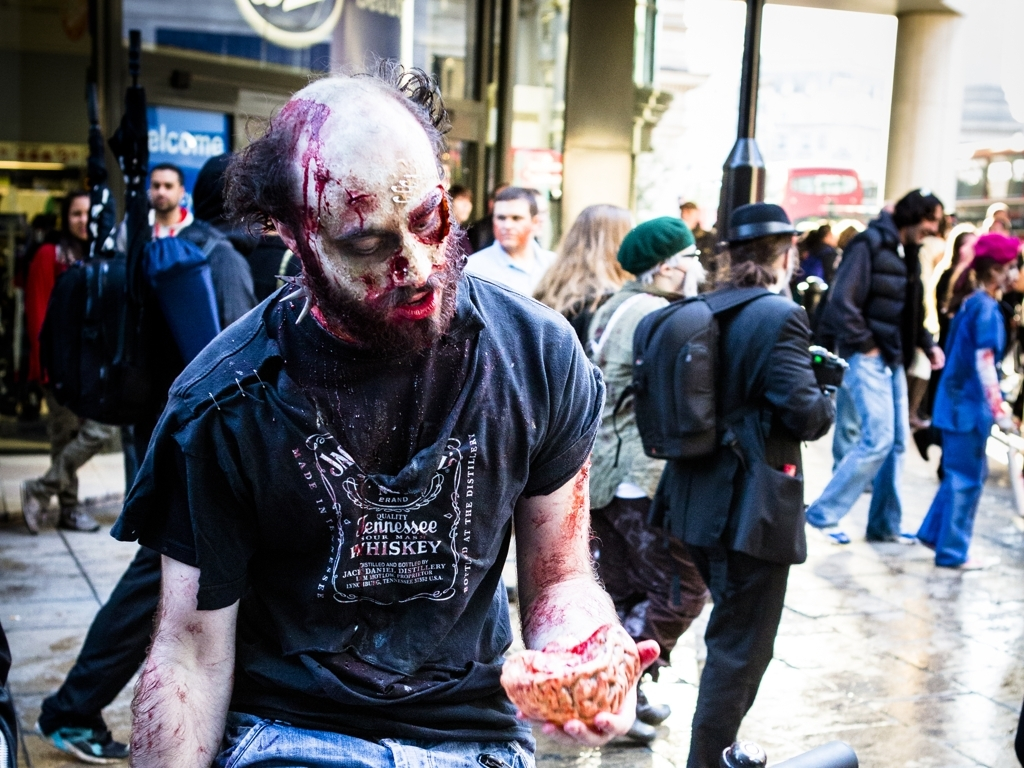Can you describe the person's attire and makeup? Certainly! The individual in the photo is wearing a short-sleeved, black T-shirt with a logo that reads 'Tennessee Whiskey Jack Daniel' on it, suggesting a casual attire. The notable aspect of their appearance, however, is the extremely detailed and gruesome zombie makeup. It includes pale, mottled skin, darkened eye sockets, fake blood, and what appear to be prosthetic wounds. Such meticulous attention to detail indicates a festive or entertainment context, possibly a themed event. 